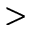<formula> <loc_0><loc_0><loc_500><loc_500>></formula> 